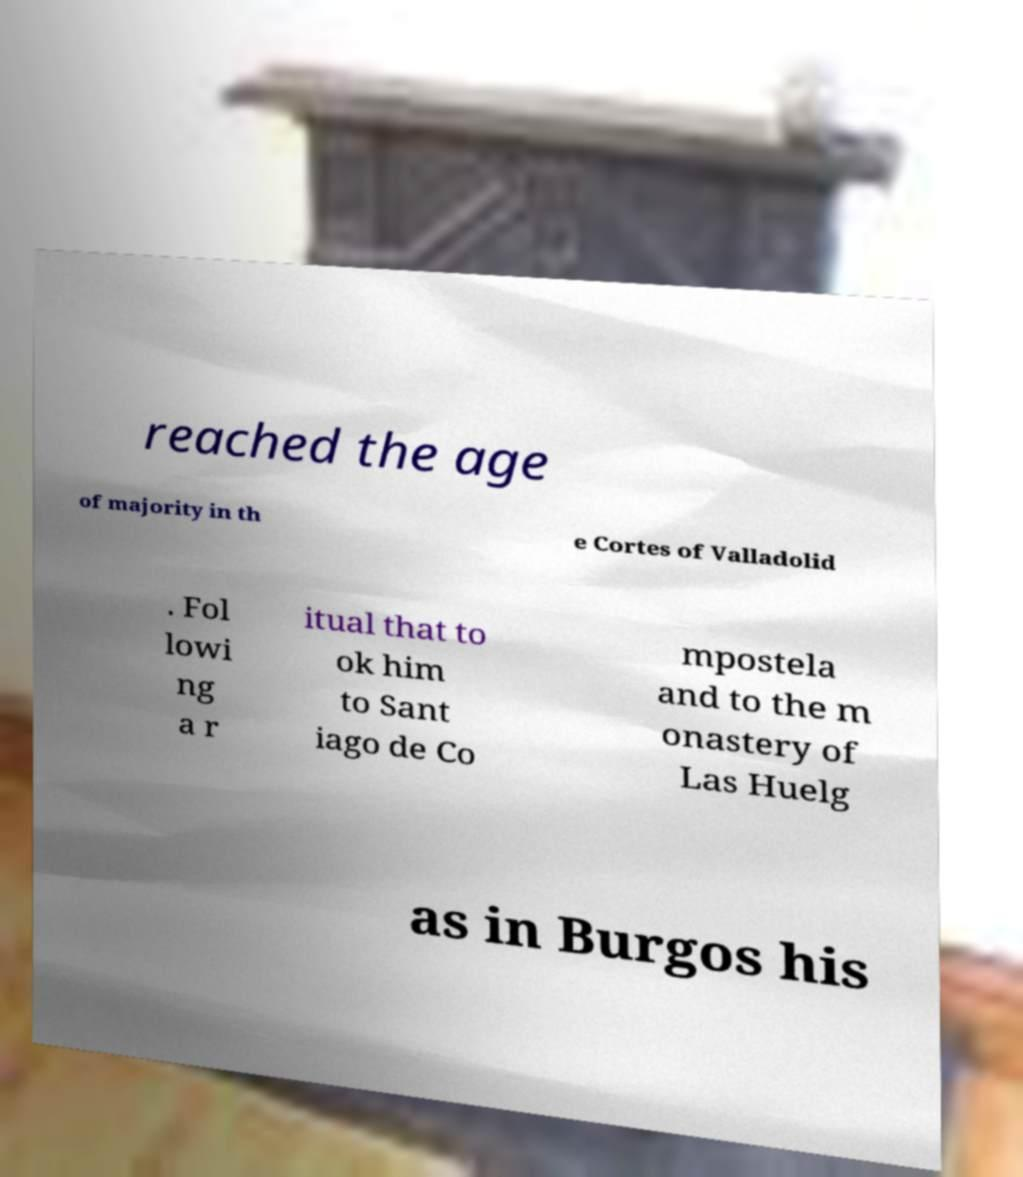Please identify and transcribe the text found in this image. reached the age of majority in th e Cortes of Valladolid . Fol lowi ng a r itual that to ok him to Sant iago de Co mpostela and to the m onastery of Las Huelg as in Burgos his 